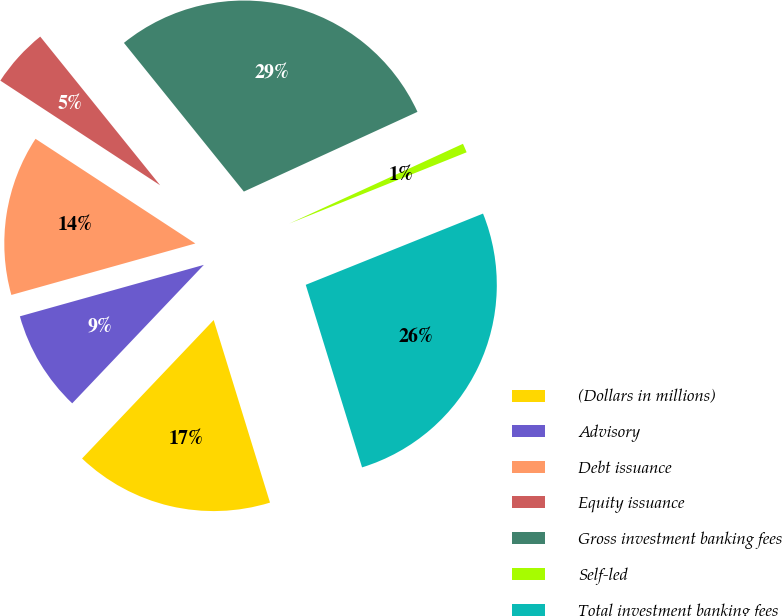Convert chart to OTSL. <chart><loc_0><loc_0><loc_500><loc_500><pie_chart><fcel>(Dollars in millions)<fcel>Advisory<fcel>Debt issuance<fcel>Equity issuance<fcel>Gross investment banking fees<fcel>Self-led<fcel>Total investment banking fees<nl><fcel>16.86%<fcel>8.56%<fcel>13.57%<fcel>4.97%<fcel>28.95%<fcel>0.77%<fcel>26.32%<nl></chart> 